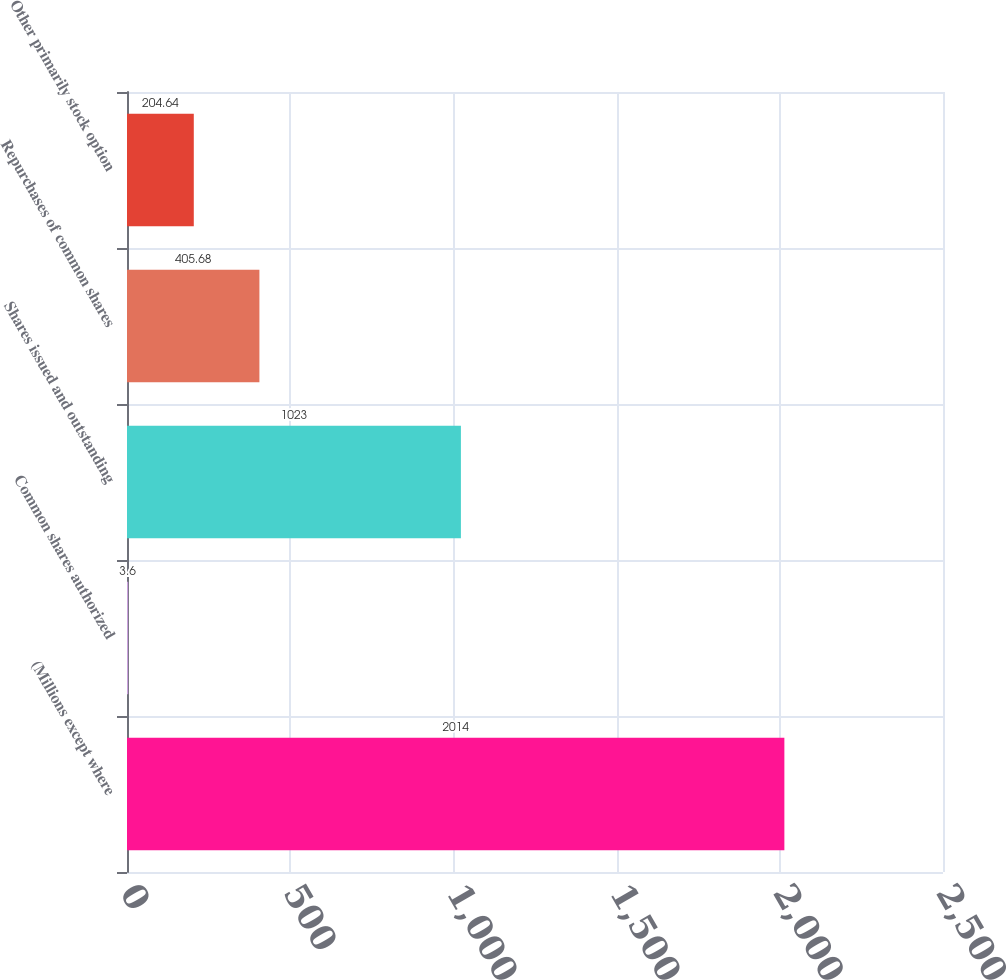Convert chart. <chart><loc_0><loc_0><loc_500><loc_500><bar_chart><fcel>(Millions except where<fcel>Common shares authorized<fcel>Shares issued and outstanding<fcel>Repurchases of common shares<fcel>Other primarily stock option<nl><fcel>2014<fcel>3.6<fcel>1023<fcel>405.68<fcel>204.64<nl></chart> 